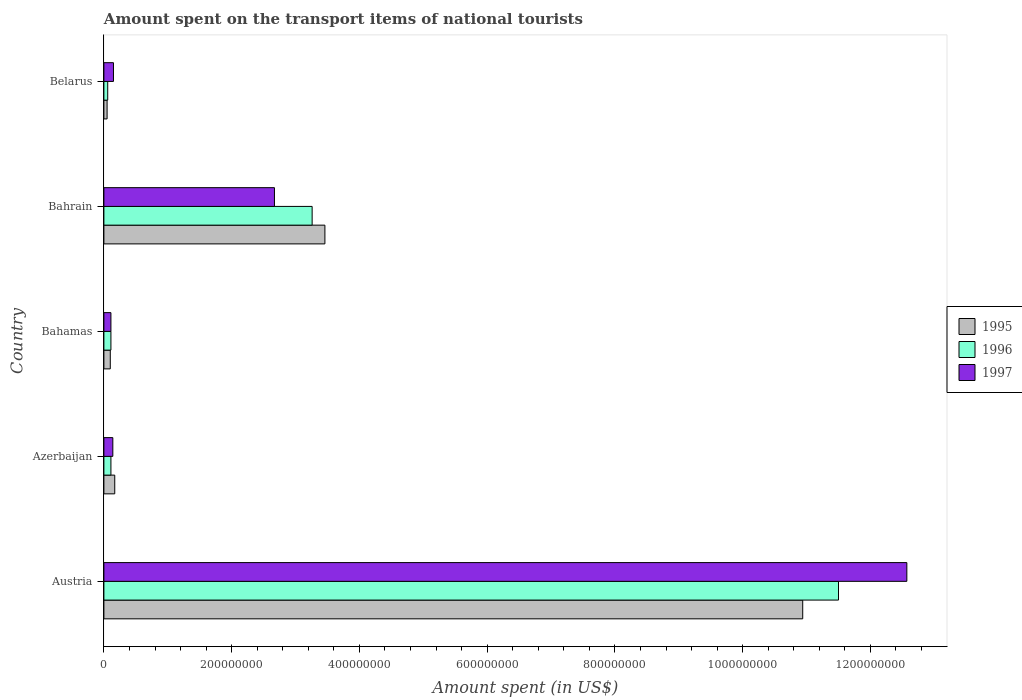How many different coloured bars are there?
Provide a short and direct response. 3. How many groups of bars are there?
Make the answer very short. 5. Are the number of bars per tick equal to the number of legend labels?
Make the answer very short. Yes. Are the number of bars on each tick of the Y-axis equal?
Make the answer very short. Yes. What is the label of the 3rd group of bars from the top?
Your answer should be compact. Bahamas. What is the amount spent on the transport items of national tourists in 1997 in Bahrain?
Ensure brevity in your answer.  2.67e+08. Across all countries, what is the maximum amount spent on the transport items of national tourists in 1995?
Ensure brevity in your answer.  1.09e+09. In which country was the amount spent on the transport items of national tourists in 1995 minimum?
Your answer should be very brief. Belarus. What is the total amount spent on the transport items of national tourists in 1995 in the graph?
Your answer should be very brief. 1.47e+09. What is the difference between the amount spent on the transport items of national tourists in 1996 in Bahamas and that in Bahrain?
Provide a succinct answer. -3.15e+08. What is the difference between the amount spent on the transport items of national tourists in 1996 in Bahamas and the amount spent on the transport items of national tourists in 1997 in Austria?
Your answer should be very brief. -1.25e+09. What is the average amount spent on the transport items of national tourists in 1996 per country?
Provide a short and direct response. 3.01e+08. What is the difference between the amount spent on the transport items of national tourists in 1995 and amount spent on the transport items of national tourists in 1997 in Bahamas?
Offer a terse response. -1.00e+06. In how many countries, is the amount spent on the transport items of national tourists in 1997 greater than 880000000 US$?
Provide a short and direct response. 1. What is the ratio of the amount spent on the transport items of national tourists in 1997 in Austria to that in Belarus?
Offer a terse response. 83.8. What is the difference between the highest and the second highest amount spent on the transport items of national tourists in 1997?
Offer a very short reply. 9.90e+08. What is the difference between the highest and the lowest amount spent on the transport items of national tourists in 1997?
Give a very brief answer. 1.25e+09. In how many countries, is the amount spent on the transport items of national tourists in 1995 greater than the average amount spent on the transport items of national tourists in 1995 taken over all countries?
Make the answer very short. 2. Is the sum of the amount spent on the transport items of national tourists in 1995 in Azerbaijan and Bahrain greater than the maximum amount spent on the transport items of national tourists in 1996 across all countries?
Make the answer very short. No. What does the 2nd bar from the bottom in Belarus represents?
Provide a short and direct response. 1996. Is it the case that in every country, the sum of the amount spent on the transport items of national tourists in 1995 and amount spent on the transport items of national tourists in 1996 is greater than the amount spent on the transport items of national tourists in 1997?
Ensure brevity in your answer.  No. How many countries are there in the graph?
Make the answer very short. 5. What is the difference between two consecutive major ticks on the X-axis?
Make the answer very short. 2.00e+08. Are the values on the major ticks of X-axis written in scientific E-notation?
Offer a terse response. No. Does the graph contain grids?
Your answer should be very brief. No. What is the title of the graph?
Your response must be concise. Amount spent on the transport items of national tourists. What is the label or title of the X-axis?
Your response must be concise. Amount spent (in US$). What is the Amount spent (in US$) in 1995 in Austria?
Give a very brief answer. 1.09e+09. What is the Amount spent (in US$) in 1996 in Austria?
Provide a short and direct response. 1.15e+09. What is the Amount spent (in US$) in 1997 in Austria?
Ensure brevity in your answer.  1.26e+09. What is the Amount spent (in US$) of 1995 in Azerbaijan?
Provide a succinct answer. 1.70e+07. What is the Amount spent (in US$) in 1996 in Azerbaijan?
Make the answer very short. 1.10e+07. What is the Amount spent (in US$) in 1997 in Azerbaijan?
Provide a succinct answer. 1.40e+07. What is the Amount spent (in US$) in 1995 in Bahamas?
Ensure brevity in your answer.  1.00e+07. What is the Amount spent (in US$) in 1996 in Bahamas?
Ensure brevity in your answer.  1.10e+07. What is the Amount spent (in US$) in 1997 in Bahamas?
Your answer should be compact. 1.10e+07. What is the Amount spent (in US$) of 1995 in Bahrain?
Provide a succinct answer. 3.46e+08. What is the Amount spent (in US$) of 1996 in Bahrain?
Provide a short and direct response. 3.26e+08. What is the Amount spent (in US$) of 1997 in Bahrain?
Your answer should be compact. 2.67e+08. What is the Amount spent (in US$) of 1997 in Belarus?
Give a very brief answer. 1.50e+07. Across all countries, what is the maximum Amount spent (in US$) of 1995?
Ensure brevity in your answer.  1.09e+09. Across all countries, what is the maximum Amount spent (in US$) of 1996?
Give a very brief answer. 1.15e+09. Across all countries, what is the maximum Amount spent (in US$) of 1997?
Ensure brevity in your answer.  1.26e+09. Across all countries, what is the minimum Amount spent (in US$) in 1995?
Ensure brevity in your answer.  5.00e+06. Across all countries, what is the minimum Amount spent (in US$) of 1996?
Offer a very short reply. 6.00e+06. Across all countries, what is the minimum Amount spent (in US$) of 1997?
Your answer should be compact. 1.10e+07. What is the total Amount spent (in US$) of 1995 in the graph?
Your response must be concise. 1.47e+09. What is the total Amount spent (in US$) of 1996 in the graph?
Give a very brief answer. 1.50e+09. What is the total Amount spent (in US$) in 1997 in the graph?
Offer a terse response. 1.56e+09. What is the difference between the Amount spent (in US$) of 1995 in Austria and that in Azerbaijan?
Your response must be concise. 1.08e+09. What is the difference between the Amount spent (in US$) in 1996 in Austria and that in Azerbaijan?
Offer a terse response. 1.14e+09. What is the difference between the Amount spent (in US$) in 1997 in Austria and that in Azerbaijan?
Provide a short and direct response. 1.24e+09. What is the difference between the Amount spent (in US$) of 1995 in Austria and that in Bahamas?
Provide a succinct answer. 1.08e+09. What is the difference between the Amount spent (in US$) of 1996 in Austria and that in Bahamas?
Keep it short and to the point. 1.14e+09. What is the difference between the Amount spent (in US$) in 1997 in Austria and that in Bahamas?
Your answer should be compact. 1.25e+09. What is the difference between the Amount spent (in US$) in 1995 in Austria and that in Bahrain?
Provide a short and direct response. 7.48e+08. What is the difference between the Amount spent (in US$) of 1996 in Austria and that in Bahrain?
Make the answer very short. 8.24e+08. What is the difference between the Amount spent (in US$) in 1997 in Austria and that in Bahrain?
Provide a succinct answer. 9.90e+08. What is the difference between the Amount spent (in US$) of 1995 in Austria and that in Belarus?
Provide a succinct answer. 1.09e+09. What is the difference between the Amount spent (in US$) in 1996 in Austria and that in Belarus?
Ensure brevity in your answer.  1.14e+09. What is the difference between the Amount spent (in US$) of 1997 in Austria and that in Belarus?
Keep it short and to the point. 1.24e+09. What is the difference between the Amount spent (in US$) in 1995 in Azerbaijan and that in Bahamas?
Offer a terse response. 7.00e+06. What is the difference between the Amount spent (in US$) in 1996 in Azerbaijan and that in Bahamas?
Your answer should be compact. 0. What is the difference between the Amount spent (in US$) in 1995 in Azerbaijan and that in Bahrain?
Offer a very short reply. -3.29e+08. What is the difference between the Amount spent (in US$) in 1996 in Azerbaijan and that in Bahrain?
Your answer should be compact. -3.15e+08. What is the difference between the Amount spent (in US$) of 1997 in Azerbaijan and that in Bahrain?
Make the answer very short. -2.53e+08. What is the difference between the Amount spent (in US$) in 1996 in Azerbaijan and that in Belarus?
Give a very brief answer. 5.00e+06. What is the difference between the Amount spent (in US$) of 1997 in Azerbaijan and that in Belarus?
Offer a very short reply. -1.00e+06. What is the difference between the Amount spent (in US$) in 1995 in Bahamas and that in Bahrain?
Make the answer very short. -3.36e+08. What is the difference between the Amount spent (in US$) of 1996 in Bahamas and that in Bahrain?
Provide a short and direct response. -3.15e+08. What is the difference between the Amount spent (in US$) of 1997 in Bahamas and that in Bahrain?
Keep it short and to the point. -2.56e+08. What is the difference between the Amount spent (in US$) in 1995 in Bahamas and that in Belarus?
Offer a very short reply. 5.00e+06. What is the difference between the Amount spent (in US$) in 1996 in Bahamas and that in Belarus?
Keep it short and to the point. 5.00e+06. What is the difference between the Amount spent (in US$) in 1997 in Bahamas and that in Belarus?
Provide a succinct answer. -4.00e+06. What is the difference between the Amount spent (in US$) in 1995 in Bahrain and that in Belarus?
Provide a short and direct response. 3.41e+08. What is the difference between the Amount spent (in US$) of 1996 in Bahrain and that in Belarus?
Your answer should be very brief. 3.20e+08. What is the difference between the Amount spent (in US$) in 1997 in Bahrain and that in Belarus?
Provide a succinct answer. 2.52e+08. What is the difference between the Amount spent (in US$) in 1995 in Austria and the Amount spent (in US$) in 1996 in Azerbaijan?
Provide a short and direct response. 1.08e+09. What is the difference between the Amount spent (in US$) in 1995 in Austria and the Amount spent (in US$) in 1997 in Azerbaijan?
Provide a short and direct response. 1.08e+09. What is the difference between the Amount spent (in US$) in 1996 in Austria and the Amount spent (in US$) in 1997 in Azerbaijan?
Offer a terse response. 1.14e+09. What is the difference between the Amount spent (in US$) in 1995 in Austria and the Amount spent (in US$) in 1996 in Bahamas?
Offer a very short reply. 1.08e+09. What is the difference between the Amount spent (in US$) of 1995 in Austria and the Amount spent (in US$) of 1997 in Bahamas?
Ensure brevity in your answer.  1.08e+09. What is the difference between the Amount spent (in US$) in 1996 in Austria and the Amount spent (in US$) in 1997 in Bahamas?
Provide a succinct answer. 1.14e+09. What is the difference between the Amount spent (in US$) of 1995 in Austria and the Amount spent (in US$) of 1996 in Bahrain?
Keep it short and to the point. 7.68e+08. What is the difference between the Amount spent (in US$) in 1995 in Austria and the Amount spent (in US$) in 1997 in Bahrain?
Your answer should be very brief. 8.27e+08. What is the difference between the Amount spent (in US$) of 1996 in Austria and the Amount spent (in US$) of 1997 in Bahrain?
Your response must be concise. 8.83e+08. What is the difference between the Amount spent (in US$) in 1995 in Austria and the Amount spent (in US$) in 1996 in Belarus?
Provide a succinct answer. 1.09e+09. What is the difference between the Amount spent (in US$) in 1995 in Austria and the Amount spent (in US$) in 1997 in Belarus?
Your answer should be compact. 1.08e+09. What is the difference between the Amount spent (in US$) in 1996 in Austria and the Amount spent (in US$) in 1997 in Belarus?
Keep it short and to the point. 1.14e+09. What is the difference between the Amount spent (in US$) in 1995 in Azerbaijan and the Amount spent (in US$) in 1996 in Bahrain?
Ensure brevity in your answer.  -3.09e+08. What is the difference between the Amount spent (in US$) in 1995 in Azerbaijan and the Amount spent (in US$) in 1997 in Bahrain?
Give a very brief answer. -2.50e+08. What is the difference between the Amount spent (in US$) of 1996 in Azerbaijan and the Amount spent (in US$) of 1997 in Bahrain?
Offer a very short reply. -2.56e+08. What is the difference between the Amount spent (in US$) in 1995 in Azerbaijan and the Amount spent (in US$) in 1996 in Belarus?
Your response must be concise. 1.10e+07. What is the difference between the Amount spent (in US$) of 1996 in Azerbaijan and the Amount spent (in US$) of 1997 in Belarus?
Your answer should be very brief. -4.00e+06. What is the difference between the Amount spent (in US$) of 1995 in Bahamas and the Amount spent (in US$) of 1996 in Bahrain?
Make the answer very short. -3.16e+08. What is the difference between the Amount spent (in US$) of 1995 in Bahamas and the Amount spent (in US$) of 1997 in Bahrain?
Your response must be concise. -2.57e+08. What is the difference between the Amount spent (in US$) of 1996 in Bahamas and the Amount spent (in US$) of 1997 in Bahrain?
Offer a very short reply. -2.56e+08. What is the difference between the Amount spent (in US$) of 1995 in Bahamas and the Amount spent (in US$) of 1996 in Belarus?
Your answer should be compact. 4.00e+06. What is the difference between the Amount spent (in US$) in 1995 in Bahamas and the Amount spent (in US$) in 1997 in Belarus?
Ensure brevity in your answer.  -5.00e+06. What is the difference between the Amount spent (in US$) in 1996 in Bahamas and the Amount spent (in US$) in 1997 in Belarus?
Provide a succinct answer. -4.00e+06. What is the difference between the Amount spent (in US$) of 1995 in Bahrain and the Amount spent (in US$) of 1996 in Belarus?
Provide a short and direct response. 3.40e+08. What is the difference between the Amount spent (in US$) in 1995 in Bahrain and the Amount spent (in US$) in 1997 in Belarus?
Keep it short and to the point. 3.31e+08. What is the difference between the Amount spent (in US$) in 1996 in Bahrain and the Amount spent (in US$) in 1997 in Belarus?
Give a very brief answer. 3.11e+08. What is the average Amount spent (in US$) of 1995 per country?
Provide a short and direct response. 2.94e+08. What is the average Amount spent (in US$) in 1996 per country?
Your answer should be very brief. 3.01e+08. What is the average Amount spent (in US$) in 1997 per country?
Keep it short and to the point. 3.13e+08. What is the difference between the Amount spent (in US$) of 1995 and Amount spent (in US$) of 1996 in Austria?
Offer a very short reply. -5.60e+07. What is the difference between the Amount spent (in US$) of 1995 and Amount spent (in US$) of 1997 in Austria?
Provide a short and direct response. -1.63e+08. What is the difference between the Amount spent (in US$) in 1996 and Amount spent (in US$) in 1997 in Austria?
Your answer should be compact. -1.07e+08. What is the difference between the Amount spent (in US$) in 1995 and Amount spent (in US$) in 1996 in Azerbaijan?
Provide a succinct answer. 6.00e+06. What is the difference between the Amount spent (in US$) of 1995 and Amount spent (in US$) of 1997 in Azerbaijan?
Give a very brief answer. 3.00e+06. What is the difference between the Amount spent (in US$) of 1995 and Amount spent (in US$) of 1996 in Bahamas?
Offer a very short reply. -1.00e+06. What is the difference between the Amount spent (in US$) of 1996 and Amount spent (in US$) of 1997 in Bahamas?
Your answer should be compact. 0. What is the difference between the Amount spent (in US$) in 1995 and Amount spent (in US$) in 1996 in Bahrain?
Your answer should be compact. 2.00e+07. What is the difference between the Amount spent (in US$) of 1995 and Amount spent (in US$) of 1997 in Bahrain?
Give a very brief answer. 7.90e+07. What is the difference between the Amount spent (in US$) of 1996 and Amount spent (in US$) of 1997 in Bahrain?
Your answer should be very brief. 5.90e+07. What is the difference between the Amount spent (in US$) in 1995 and Amount spent (in US$) in 1997 in Belarus?
Your answer should be compact. -1.00e+07. What is the difference between the Amount spent (in US$) of 1996 and Amount spent (in US$) of 1997 in Belarus?
Make the answer very short. -9.00e+06. What is the ratio of the Amount spent (in US$) in 1995 in Austria to that in Azerbaijan?
Your answer should be compact. 64.35. What is the ratio of the Amount spent (in US$) of 1996 in Austria to that in Azerbaijan?
Ensure brevity in your answer.  104.55. What is the ratio of the Amount spent (in US$) of 1997 in Austria to that in Azerbaijan?
Keep it short and to the point. 89.79. What is the ratio of the Amount spent (in US$) in 1995 in Austria to that in Bahamas?
Your answer should be very brief. 109.4. What is the ratio of the Amount spent (in US$) in 1996 in Austria to that in Bahamas?
Provide a short and direct response. 104.55. What is the ratio of the Amount spent (in US$) of 1997 in Austria to that in Bahamas?
Provide a short and direct response. 114.27. What is the ratio of the Amount spent (in US$) of 1995 in Austria to that in Bahrain?
Give a very brief answer. 3.16. What is the ratio of the Amount spent (in US$) in 1996 in Austria to that in Bahrain?
Your answer should be compact. 3.53. What is the ratio of the Amount spent (in US$) of 1997 in Austria to that in Bahrain?
Provide a succinct answer. 4.71. What is the ratio of the Amount spent (in US$) of 1995 in Austria to that in Belarus?
Your answer should be very brief. 218.8. What is the ratio of the Amount spent (in US$) of 1996 in Austria to that in Belarus?
Your answer should be very brief. 191.67. What is the ratio of the Amount spent (in US$) of 1997 in Austria to that in Belarus?
Ensure brevity in your answer.  83.8. What is the ratio of the Amount spent (in US$) in 1995 in Azerbaijan to that in Bahamas?
Your answer should be very brief. 1.7. What is the ratio of the Amount spent (in US$) of 1997 in Azerbaijan to that in Bahamas?
Your answer should be very brief. 1.27. What is the ratio of the Amount spent (in US$) in 1995 in Azerbaijan to that in Bahrain?
Your response must be concise. 0.05. What is the ratio of the Amount spent (in US$) in 1996 in Azerbaijan to that in Bahrain?
Your response must be concise. 0.03. What is the ratio of the Amount spent (in US$) of 1997 in Azerbaijan to that in Bahrain?
Your answer should be very brief. 0.05. What is the ratio of the Amount spent (in US$) in 1996 in Azerbaijan to that in Belarus?
Offer a very short reply. 1.83. What is the ratio of the Amount spent (in US$) of 1997 in Azerbaijan to that in Belarus?
Give a very brief answer. 0.93. What is the ratio of the Amount spent (in US$) in 1995 in Bahamas to that in Bahrain?
Keep it short and to the point. 0.03. What is the ratio of the Amount spent (in US$) of 1996 in Bahamas to that in Bahrain?
Offer a very short reply. 0.03. What is the ratio of the Amount spent (in US$) in 1997 in Bahamas to that in Bahrain?
Make the answer very short. 0.04. What is the ratio of the Amount spent (in US$) in 1995 in Bahamas to that in Belarus?
Make the answer very short. 2. What is the ratio of the Amount spent (in US$) of 1996 in Bahamas to that in Belarus?
Provide a succinct answer. 1.83. What is the ratio of the Amount spent (in US$) of 1997 in Bahamas to that in Belarus?
Provide a succinct answer. 0.73. What is the ratio of the Amount spent (in US$) of 1995 in Bahrain to that in Belarus?
Offer a very short reply. 69.2. What is the ratio of the Amount spent (in US$) of 1996 in Bahrain to that in Belarus?
Your answer should be very brief. 54.33. What is the difference between the highest and the second highest Amount spent (in US$) in 1995?
Your answer should be compact. 7.48e+08. What is the difference between the highest and the second highest Amount spent (in US$) of 1996?
Give a very brief answer. 8.24e+08. What is the difference between the highest and the second highest Amount spent (in US$) of 1997?
Keep it short and to the point. 9.90e+08. What is the difference between the highest and the lowest Amount spent (in US$) of 1995?
Your response must be concise. 1.09e+09. What is the difference between the highest and the lowest Amount spent (in US$) of 1996?
Offer a very short reply. 1.14e+09. What is the difference between the highest and the lowest Amount spent (in US$) in 1997?
Ensure brevity in your answer.  1.25e+09. 